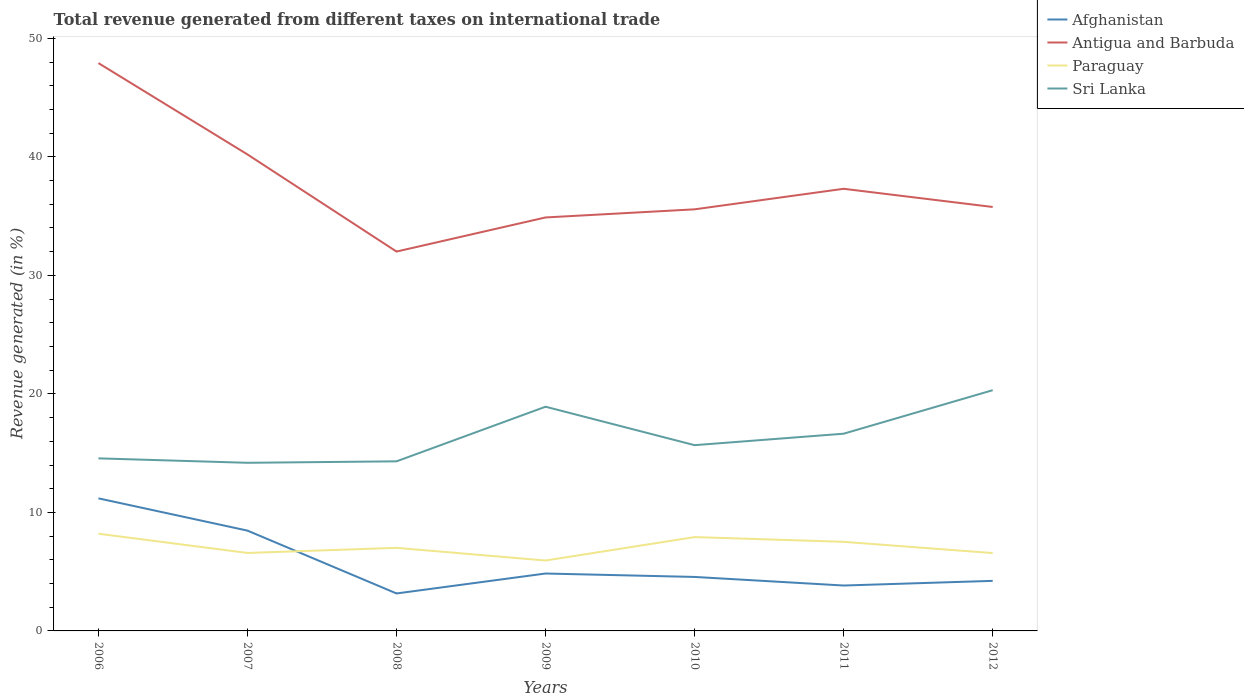Does the line corresponding to Paraguay intersect with the line corresponding to Sri Lanka?
Provide a short and direct response. No. Across all years, what is the maximum total revenue generated in Afghanistan?
Offer a very short reply. 3.16. What is the total total revenue generated in Antigua and Barbuda in the graph?
Provide a short and direct response. 12.34. What is the difference between the highest and the second highest total revenue generated in Paraguay?
Provide a succinct answer. 2.26. What is the difference between the highest and the lowest total revenue generated in Afghanistan?
Your answer should be compact. 2. How many lines are there?
Offer a terse response. 4. How many years are there in the graph?
Keep it short and to the point. 7. Does the graph contain any zero values?
Offer a terse response. No. Where does the legend appear in the graph?
Ensure brevity in your answer.  Top right. How many legend labels are there?
Ensure brevity in your answer.  4. What is the title of the graph?
Ensure brevity in your answer.  Total revenue generated from different taxes on international trade. Does "South Asia" appear as one of the legend labels in the graph?
Provide a short and direct response. No. What is the label or title of the X-axis?
Provide a succinct answer. Years. What is the label or title of the Y-axis?
Make the answer very short. Revenue generated (in %). What is the Revenue generated (in %) of Afghanistan in 2006?
Your answer should be compact. 11.19. What is the Revenue generated (in %) in Antigua and Barbuda in 2006?
Provide a short and direct response. 47.91. What is the Revenue generated (in %) in Paraguay in 2006?
Give a very brief answer. 8.2. What is the Revenue generated (in %) of Sri Lanka in 2006?
Provide a short and direct response. 14.56. What is the Revenue generated (in %) in Afghanistan in 2007?
Make the answer very short. 8.46. What is the Revenue generated (in %) of Antigua and Barbuda in 2007?
Your answer should be compact. 40.2. What is the Revenue generated (in %) in Paraguay in 2007?
Give a very brief answer. 6.58. What is the Revenue generated (in %) of Sri Lanka in 2007?
Your answer should be very brief. 14.19. What is the Revenue generated (in %) in Afghanistan in 2008?
Offer a very short reply. 3.16. What is the Revenue generated (in %) in Antigua and Barbuda in 2008?
Offer a terse response. 32.01. What is the Revenue generated (in %) in Paraguay in 2008?
Your response must be concise. 7.01. What is the Revenue generated (in %) in Sri Lanka in 2008?
Make the answer very short. 14.31. What is the Revenue generated (in %) of Afghanistan in 2009?
Your response must be concise. 4.84. What is the Revenue generated (in %) in Antigua and Barbuda in 2009?
Provide a succinct answer. 34.89. What is the Revenue generated (in %) in Paraguay in 2009?
Make the answer very short. 5.94. What is the Revenue generated (in %) in Sri Lanka in 2009?
Your answer should be very brief. 18.92. What is the Revenue generated (in %) in Afghanistan in 2010?
Provide a short and direct response. 4.55. What is the Revenue generated (in %) of Antigua and Barbuda in 2010?
Provide a succinct answer. 35.57. What is the Revenue generated (in %) of Paraguay in 2010?
Provide a short and direct response. 7.92. What is the Revenue generated (in %) of Sri Lanka in 2010?
Keep it short and to the point. 15.67. What is the Revenue generated (in %) in Afghanistan in 2011?
Provide a short and direct response. 3.83. What is the Revenue generated (in %) in Antigua and Barbuda in 2011?
Your answer should be very brief. 37.31. What is the Revenue generated (in %) in Paraguay in 2011?
Give a very brief answer. 7.52. What is the Revenue generated (in %) of Sri Lanka in 2011?
Offer a very short reply. 16.64. What is the Revenue generated (in %) of Afghanistan in 2012?
Keep it short and to the point. 4.22. What is the Revenue generated (in %) in Antigua and Barbuda in 2012?
Offer a terse response. 35.77. What is the Revenue generated (in %) of Paraguay in 2012?
Offer a very short reply. 6.57. What is the Revenue generated (in %) of Sri Lanka in 2012?
Your response must be concise. 20.31. Across all years, what is the maximum Revenue generated (in %) in Afghanistan?
Provide a succinct answer. 11.19. Across all years, what is the maximum Revenue generated (in %) in Antigua and Barbuda?
Your answer should be compact. 47.91. Across all years, what is the maximum Revenue generated (in %) in Paraguay?
Your answer should be very brief. 8.2. Across all years, what is the maximum Revenue generated (in %) in Sri Lanka?
Your response must be concise. 20.31. Across all years, what is the minimum Revenue generated (in %) in Afghanistan?
Offer a very short reply. 3.16. Across all years, what is the minimum Revenue generated (in %) in Antigua and Barbuda?
Your response must be concise. 32.01. Across all years, what is the minimum Revenue generated (in %) of Paraguay?
Give a very brief answer. 5.94. Across all years, what is the minimum Revenue generated (in %) of Sri Lanka?
Your response must be concise. 14.19. What is the total Revenue generated (in %) of Afghanistan in the graph?
Your response must be concise. 40.27. What is the total Revenue generated (in %) of Antigua and Barbuda in the graph?
Make the answer very short. 263.67. What is the total Revenue generated (in %) of Paraguay in the graph?
Provide a succinct answer. 49.73. What is the total Revenue generated (in %) in Sri Lanka in the graph?
Offer a terse response. 114.6. What is the difference between the Revenue generated (in %) in Afghanistan in 2006 and that in 2007?
Offer a very short reply. 2.72. What is the difference between the Revenue generated (in %) in Antigua and Barbuda in 2006 and that in 2007?
Your answer should be very brief. 7.71. What is the difference between the Revenue generated (in %) in Paraguay in 2006 and that in 2007?
Your response must be concise. 1.62. What is the difference between the Revenue generated (in %) of Sri Lanka in 2006 and that in 2007?
Your answer should be compact. 0.38. What is the difference between the Revenue generated (in %) of Afghanistan in 2006 and that in 2008?
Ensure brevity in your answer.  8.02. What is the difference between the Revenue generated (in %) in Antigua and Barbuda in 2006 and that in 2008?
Keep it short and to the point. 15.9. What is the difference between the Revenue generated (in %) in Paraguay in 2006 and that in 2008?
Provide a short and direct response. 1.19. What is the difference between the Revenue generated (in %) of Sri Lanka in 2006 and that in 2008?
Make the answer very short. 0.25. What is the difference between the Revenue generated (in %) of Afghanistan in 2006 and that in 2009?
Give a very brief answer. 6.34. What is the difference between the Revenue generated (in %) in Antigua and Barbuda in 2006 and that in 2009?
Offer a terse response. 13.02. What is the difference between the Revenue generated (in %) in Paraguay in 2006 and that in 2009?
Your answer should be very brief. 2.26. What is the difference between the Revenue generated (in %) in Sri Lanka in 2006 and that in 2009?
Your answer should be very brief. -4.36. What is the difference between the Revenue generated (in %) in Afghanistan in 2006 and that in 2010?
Your response must be concise. 6.63. What is the difference between the Revenue generated (in %) of Antigua and Barbuda in 2006 and that in 2010?
Provide a succinct answer. 12.34. What is the difference between the Revenue generated (in %) of Paraguay in 2006 and that in 2010?
Offer a very short reply. 0.28. What is the difference between the Revenue generated (in %) in Sri Lanka in 2006 and that in 2010?
Your answer should be very brief. -1.11. What is the difference between the Revenue generated (in %) of Afghanistan in 2006 and that in 2011?
Offer a very short reply. 7.35. What is the difference between the Revenue generated (in %) of Antigua and Barbuda in 2006 and that in 2011?
Your answer should be compact. 10.61. What is the difference between the Revenue generated (in %) in Paraguay in 2006 and that in 2011?
Give a very brief answer. 0.68. What is the difference between the Revenue generated (in %) in Sri Lanka in 2006 and that in 2011?
Make the answer very short. -2.08. What is the difference between the Revenue generated (in %) in Afghanistan in 2006 and that in 2012?
Your answer should be compact. 6.96. What is the difference between the Revenue generated (in %) in Antigua and Barbuda in 2006 and that in 2012?
Keep it short and to the point. 12.14. What is the difference between the Revenue generated (in %) of Paraguay in 2006 and that in 2012?
Keep it short and to the point. 1.63. What is the difference between the Revenue generated (in %) of Sri Lanka in 2006 and that in 2012?
Give a very brief answer. -5.75. What is the difference between the Revenue generated (in %) of Afghanistan in 2007 and that in 2008?
Ensure brevity in your answer.  5.3. What is the difference between the Revenue generated (in %) of Antigua and Barbuda in 2007 and that in 2008?
Make the answer very short. 8.19. What is the difference between the Revenue generated (in %) in Paraguay in 2007 and that in 2008?
Your answer should be compact. -0.43. What is the difference between the Revenue generated (in %) in Sri Lanka in 2007 and that in 2008?
Provide a succinct answer. -0.12. What is the difference between the Revenue generated (in %) of Afghanistan in 2007 and that in 2009?
Keep it short and to the point. 3.62. What is the difference between the Revenue generated (in %) of Antigua and Barbuda in 2007 and that in 2009?
Provide a succinct answer. 5.32. What is the difference between the Revenue generated (in %) in Paraguay in 2007 and that in 2009?
Your response must be concise. 0.64. What is the difference between the Revenue generated (in %) of Sri Lanka in 2007 and that in 2009?
Ensure brevity in your answer.  -4.73. What is the difference between the Revenue generated (in %) of Afghanistan in 2007 and that in 2010?
Make the answer very short. 3.91. What is the difference between the Revenue generated (in %) of Antigua and Barbuda in 2007 and that in 2010?
Your response must be concise. 4.63. What is the difference between the Revenue generated (in %) in Paraguay in 2007 and that in 2010?
Your response must be concise. -1.34. What is the difference between the Revenue generated (in %) of Sri Lanka in 2007 and that in 2010?
Offer a very short reply. -1.49. What is the difference between the Revenue generated (in %) of Afghanistan in 2007 and that in 2011?
Make the answer very short. 4.63. What is the difference between the Revenue generated (in %) in Antigua and Barbuda in 2007 and that in 2011?
Provide a short and direct response. 2.9. What is the difference between the Revenue generated (in %) of Paraguay in 2007 and that in 2011?
Keep it short and to the point. -0.94. What is the difference between the Revenue generated (in %) of Sri Lanka in 2007 and that in 2011?
Your answer should be compact. -2.46. What is the difference between the Revenue generated (in %) in Afghanistan in 2007 and that in 2012?
Your answer should be compact. 4.24. What is the difference between the Revenue generated (in %) in Antigua and Barbuda in 2007 and that in 2012?
Give a very brief answer. 4.43. What is the difference between the Revenue generated (in %) in Paraguay in 2007 and that in 2012?
Make the answer very short. 0.01. What is the difference between the Revenue generated (in %) in Sri Lanka in 2007 and that in 2012?
Your answer should be compact. -6.13. What is the difference between the Revenue generated (in %) in Afghanistan in 2008 and that in 2009?
Provide a short and direct response. -1.68. What is the difference between the Revenue generated (in %) of Antigua and Barbuda in 2008 and that in 2009?
Your answer should be very brief. -2.88. What is the difference between the Revenue generated (in %) of Paraguay in 2008 and that in 2009?
Keep it short and to the point. 1.07. What is the difference between the Revenue generated (in %) of Sri Lanka in 2008 and that in 2009?
Provide a succinct answer. -4.61. What is the difference between the Revenue generated (in %) of Afghanistan in 2008 and that in 2010?
Ensure brevity in your answer.  -1.39. What is the difference between the Revenue generated (in %) of Antigua and Barbuda in 2008 and that in 2010?
Your response must be concise. -3.56. What is the difference between the Revenue generated (in %) in Paraguay in 2008 and that in 2010?
Ensure brevity in your answer.  -0.91. What is the difference between the Revenue generated (in %) of Sri Lanka in 2008 and that in 2010?
Ensure brevity in your answer.  -1.36. What is the difference between the Revenue generated (in %) of Afghanistan in 2008 and that in 2011?
Give a very brief answer. -0.67. What is the difference between the Revenue generated (in %) in Antigua and Barbuda in 2008 and that in 2011?
Offer a terse response. -5.3. What is the difference between the Revenue generated (in %) in Paraguay in 2008 and that in 2011?
Offer a terse response. -0.51. What is the difference between the Revenue generated (in %) of Sri Lanka in 2008 and that in 2011?
Keep it short and to the point. -2.33. What is the difference between the Revenue generated (in %) of Afghanistan in 2008 and that in 2012?
Make the answer very short. -1.06. What is the difference between the Revenue generated (in %) in Antigua and Barbuda in 2008 and that in 2012?
Provide a short and direct response. -3.76. What is the difference between the Revenue generated (in %) of Paraguay in 2008 and that in 2012?
Offer a very short reply. 0.44. What is the difference between the Revenue generated (in %) of Sri Lanka in 2008 and that in 2012?
Your answer should be very brief. -6. What is the difference between the Revenue generated (in %) in Afghanistan in 2009 and that in 2010?
Offer a very short reply. 0.29. What is the difference between the Revenue generated (in %) in Antigua and Barbuda in 2009 and that in 2010?
Provide a short and direct response. -0.69. What is the difference between the Revenue generated (in %) of Paraguay in 2009 and that in 2010?
Give a very brief answer. -1.98. What is the difference between the Revenue generated (in %) in Sri Lanka in 2009 and that in 2010?
Your response must be concise. 3.24. What is the difference between the Revenue generated (in %) of Afghanistan in 2009 and that in 2011?
Your answer should be very brief. 1.01. What is the difference between the Revenue generated (in %) of Antigua and Barbuda in 2009 and that in 2011?
Provide a short and direct response. -2.42. What is the difference between the Revenue generated (in %) in Paraguay in 2009 and that in 2011?
Offer a very short reply. -1.58. What is the difference between the Revenue generated (in %) of Sri Lanka in 2009 and that in 2011?
Make the answer very short. 2.28. What is the difference between the Revenue generated (in %) in Afghanistan in 2009 and that in 2012?
Provide a succinct answer. 0.62. What is the difference between the Revenue generated (in %) of Antigua and Barbuda in 2009 and that in 2012?
Ensure brevity in your answer.  -0.88. What is the difference between the Revenue generated (in %) of Paraguay in 2009 and that in 2012?
Ensure brevity in your answer.  -0.63. What is the difference between the Revenue generated (in %) of Sri Lanka in 2009 and that in 2012?
Your response must be concise. -1.39. What is the difference between the Revenue generated (in %) of Afghanistan in 2010 and that in 2011?
Your answer should be very brief. 0.72. What is the difference between the Revenue generated (in %) of Antigua and Barbuda in 2010 and that in 2011?
Your answer should be very brief. -1.73. What is the difference between the Revenue generated (in %) of Paraguay in 2010 and that in 2011?
Offer a terse response. 0.4. What is the difference between the Revenue generated (in %) of Sri Lanka in 2010 and that in 2011?
Provide a succinct answer. -0.97. What is the difference between the Revenue generated (in %) of Afghanistan in 2010 and that in 2012?
Make the answer very short. 0.33. What is the difference between the Revenue generated (in %) in Antigua and Barbuda in 2010 and that in 2012?
Offer a very short reply. -0.2. What is the difference between the Revenue generated (in %) of Paraguay in 2010 and that in 2012?
Your answer should be compact. 1.35. What is the difference between the Revenue generated (in %) in Sri Lanka in 2010 and that in 2012?
Give a very brief answer. -4.64. What is the difference between the Revenue generated (in %) of Afghanistan in 2011 and that in 2012?
Ensure brevity in your answer.  -0.39. What is the difference between the Revenue generated (in %) in Antigua and Barbuda in 2011 and that in 2012?
Provide a short and direct response. 1.53. What is the difference between the Revenue generated (in %) in Paraguay in 2011 and that in 2012?
Offer a terse response. 0.95. What is the difference between the Revenue generated (in %) in Sri Lanka in 2011 and that in 2012?
Offer a very short reply. -3.67. What is the difference between the Revenue generated (in %) in Afghanistan in 2006 and the Revenue generated (in %) in Antigua and Barbuda in 2007?
Offer a terse response. -29.02. What is the difference between the Revenue generated (in %) of Afghanistan in 2006 and the Revenue generated (in %) of Paraguay in 2007?
Offer a very short reply. 4.61. What is the difference between the Revenue generated (in %) of Afghanistan in 2006 and the Revenue generated (in %) of Sri Lanka in 2007?
Ensure brevity in your answer.  -3. What is the difference between the Revenue generated (in %) in Antigua and Barbuda in 2006 and the Revenue generated (in %) in Paraguay in 2007?
Offer a terse response. 41.33. What is the difference between the Revenue generated (in %) in Antigua and Barbuda in 2006 and the Revenue generated (in %) in Sri Lanka in 2007?
Keep it short and to the point. 33.73. What is the difference between the Revenue generated (in %) in Paraguay in 2006 and the Revenue generated (in %) in Sri Lanka in 2007?
Give a very brief answer. -5.98. What is the difference between the Revenue generated (in %) in Afghanistan in 2006 and the Revenue generated (in %) in Antigua and Barbuda in 2008?
Provide a short and direct response. -20.82. What is the difference between the Revenue generated (in %) in Afghanistan in 2006 and the Revenue generated (in %) in Paraguay in 2008?
Your answer should be compact. 4.18. What is the difference between the Revenue generated (in %) of Afghanistan in 2006 and the Revenue generated (in %) of Sri Lanka in 2008?
Provide a short and direct response. -3.12. What is the difference between the Revenue generated (in %) in Antigua and Barbuda in 2006 and the Revenue generated (in %) in Paraguay in 2008?
Offer a very short reply. 40.9. What is the difference between the Revenue generated (in %) in Antigua and Barbuda in 2006 and the Revenue generated (in %) in Sri Lanka in 2008?
Ensure brevity in your answer.  33.6. What is the difference between the Revenue generated (in %) in Paraguay in 2006 and the Revenue generated (in %) in Sri Lanka in 2008?
Your response must be concise. -6.11. What is the difference between the Revenue generated (in %) in Afghanistan in 2006 and the Revenue generated (in %) in Antigua and Barbuda in 2009?
Your answer should be compact. -23.7. What is the difference between the Revenue generated (in %) of Afghanistan in 2006 and the Revenue generated (in %) of Paraguay in 2009?
Provide a succinct answer. 5.24. What is the difference between the Revenue generated (in %) of Afghanistan in 2006 and the Revenue generated (in %) of Sri Lanka in 2009?
Offer a terse response. -7.73. What is the difference between the Revenue generated (in %) in Antigua and Barbuda in 2006 and the Revenue generated (in %) in Paraguay in 2009?
Offer a very short reply. 41.97. What is the difference between the Revenue generated (in %) in Antigua and Barbuda in 2006 and the Revenue generated (in %) in Sri Lanka in 2009?
Provide a short and direct response. 29. What is the difference between the Revenue generated (in %) in Paraguay in 2006 and the Revenue generated (in %) in Sri Lanka in 2009?
Your answer should be very brief. -10.72. What is the difference between the Revenue generated (in %) of Afghanistan in 2006 and the Revenue generated (in %) of Antigua and Barbuda in 2010?
Keep it short and to the point. -24.39. What is the difference between the Revenue generated (in %) of Afghanistan in 2006 and the Revenue generated (in %) of Paraguay in 2010?
Your response must be concise. 3.27. What is the difference between the Revenue generated (in %) in Afghanistan in 2006 and the Revenue generated (in %) in Sri Lanka in 2010?
Your answer should be very brief. -4.49. What is the difference between the Revenue generated (in %) in Antigua and Barbuda in 2006 and the Revenue generated (in %) in Paraguay in 2010?
Your answer should be very brief. 39.99. What is the difference between the Revenue generated (in %) in Antigua and Barbuda in 2006 and the Revenue generated (in %) in Sri Lanka in 2010?
Your response must be concise. 32.24. What is the difference between the Revenue generated (in %) in Paraguay in 2006 and the Revenue generated (in %) in Sri Lanka in 2010?
Your answer should be compact. -7.47. What is the difference between the Revenue generated (in %) of Afghanistan in 2006 and the Revenue generated (in %) of Antigua and Barbuda in 2011?
Offer a very short reply. -26.12. What is the difference between the Revenue generated (in %) of Afghanistan in 2006 and the Revenue generated (in %) of Paraguay in 2011?
Provide a succinct answer. 3.67. What is the difference between the Revenue generated (in %) in Afghanistan in 2006 and the Revenue generated (in %) in Sri Lanka in 2011?
Make the answer very short. -5.46. What is the difference between the Revenue generated (in %) in Antigua and Barbuda in 2006 and the Revenue generated (in %) in Paraguay in 2011?
Provide a short and direct response. 40.4. What is the difference between the Revenue generated (in %) of Antigua and Barbuda in 2006 and the Revenue generated (in %) of Sri Lanka in 2011?
Make the answer very short. 31.27. What is the difference between the Revenue generated (in %) of Paraguay in 2006 and the Revenue generated (in %) of Sri Lanka in 2011?
Your answer should be compact. -8.44. What is the difference between the Revenue generated (in %) in Afghanistan in 2006 and the Revenue generated (in %) in Antigua and Barbuda in 2012?
Your answer should be very brief. -24.59. What is the difference between the Revenue generated (in %) in Afghanistan in 2006 and the Revenue generated (in %) in Paraguay in 2012?
Your answer should be compact. 4.62. What is the difference between the Revenue generated (in %) in Afghanistan in 2006 and the Revenue generated (in %) in Sri Lanka in 2012?
Offer a terse response. -9.13. What is the difference between the Revenue generated (in %) of Antigua and Barbuda in 2006 and the Revenue generated (in %) of Paraguay in 2012?
Make the answer very short. 41.34. What is the difference between the Revenue generated (in %) in Antigua and Barbuda in 2006 and the Revenue generated (in %) in Sri Lanka in 2012?
Offer a terse response. 27.6. What is the difference between the Revenue generated (in %) of Paraguay in 2006 and the Revenue generated (in %) of Sri Lanka in 2012?
Your response must be concise. -12.11. What is the difference between the Revenue generated (in %) in Afghanistan in 2007 and the Revenue generated (in %) in Antigua and Barbuda in 2008?
Keep it short and to the point. -23.55. What is the difference between the Revenue generated (in %) of Afghanistan in 2007 and the Revenue generated (in %) of Paraguay in 2008?
Your response must be concise. 1.45. What is the difference between the Revenue generated (in %) in Afghanistan in 2007 and the Revenue generated (in %) in Sri Lanka in 2008?
Give a very brief answer. -5.85. What is the difference between the Revenue generated (in %) of Antigua and Barbuda in 2007 and the Revenue generated (in %) of Paraguay in 2008?
Your response must be concise. 33.19. What is the difference between the Revenue generated (in %) of Antigua and Barbuda in 2007 and the Revenue generated (in %) of Sri Lanka in 2008?
Your response must be concise. 25.89. What is the difference between the Revenue generated (in %) of Paraguay in 2007 and the Revenue generated (in %) of Sri Lanka in 2008?
Keep it short and to the point. -7.73. What is the difference between the Revenue generated (in %) of Afghanistan in 2007 and the Revenue generated (in %) of Antigua and Barbuda in 2009?
Provide a short and direct response. -26.42. What is the difference between the Revenue generated (in %) in Afghanistan in 2007 and the Revenue generated (in %) in Paraguay in 2009?
Your answer should be very brief. 2.52. What is the difference between the Revenue generated (in %) of Afghanistan in 2007 and the Revenue generated (in %) of Sri Lanka in 2009?
Offer a terse response. -10.45. What is the difference between the Revenue generated (in %) in Antigua and Barbuda in 2007 and the Revenue generated (in %) in Paraguay in 2009?
Your answer should be compact. 34.26. What is the difference between the Revenue generated (in %) of Antigua and Barbuda in 2007 and the Revenue generated (in %) of Sri Lanka in 2009?
Offer a terse response. 21.29. What is the difference between the Revenue generated (in %) in Paraguay in 2007 and the Revenue generated (in %) in Sri Lanka in 2009?
Give a very brief answer. -12.34. What is the difference between the Revenue generated (in %) in Afghanistan in 2007 and the Revenue generated (in %) in Antigua and Barbuda in 2010?
Make the answer very short. -27.11. What is the difference between the Revenue generated (in %) of Afghanistan in 2007 and the Revenue generated (in %) of Paraguay in 2010?
Ensure brevity in your answer.  0.55. What is the difference between the Revenue generated (in %) in Afghanistan in 2007 and the Revenue generated (in %) in Sri Lanka in 2010?
Your answer should be compact. -7.21. What is the difference between the Revenue generated (in %) of Antigua and Barbuda in 2007 and the Revenue generated (in %) of Paraguay in 2010?
Offer a very short reply. 32.29. What is the difference between the Revenue generated (in %) in Antigua and Barbuda in 2007 and the Revenue generated (in %) in Sri Lanka in 2010?
Provide a short and direct response. 24.53. What is the difference between the Revenue generated (in %) of Paraguay in 2007 and the Revenue generated (in %) of Sri Lanka in 2010?
Provide a succinct answer. -9.09. What is the difference between the Revenue generated (in %) of Afghanistan in 2007 and the Revenue generated (in %) of Antigua and Barbuda in 2011?
Make the answer very short. -28.84. What is the difference between the Revenue generated (in %) in Afghanistan in 2007 and the Revenue generated (in %) in Paraguay in 2011?
Offer a very short reply. 0.95. What is the difference between the Revenue generated (in %) of Afghanistan in 2007 and the Revenue generated (in %) of Sri Lanka in 2011?
Your answer should be very brief. -8.18. What is the difference between the Revenue generated (in %) in Antigua and Barbuda in 2007 and the Revenue generated (in %) in Paraguay in 2011?
Keep it short and to the point. 32.69. What is the difference between the Revenue generated (in %) of Antigua and Barbuda in 2007 and the Revenue generated (in %) of Sri Lanka in 2011?
Your answer should be compact. 23.56. What is the difference between the Revenue generated (in %) of Paraguay in 2007 and the Revenue generated (in %) of Sri Lanka in 2011?
Make the answer very short. -10.06. What is the difference between the Revenue generated (in %) in Afghanistan in 2007 and the Revenue generated (in %) in Antigua and Barbuda in 2012?
Provide a short and direct response. -27.31. What is the difference between the Revenue generated (in %) in Afghanistan in 2007 and the Revenue generated (in %) in Paraguay in 2012?
Provide a short and direct response. 1.89. What is the difference between the Revenue generated (in %) in Afghanistan in 2007 and the Revenue generated (in %) in Sri Lanka in 2012?
Provide a short and direct response. -11.85. What is the difference between the Revenue generated (in %) of Antigua and Barbuda in 2007 and the Revenue generated (in %) of Paraguay in 2012?
Make the answer very short. 33.63. What is the difference between the Revenue generated (in %) of Antigua and Barbuda in 2007 and the Revenue generated (in %) of Sri Lanka in 2012?
Ensure brevity in your answer.  19.89. What is the difference between the Revenue generated (in %) of Paraguay in 2007 and the Revenue generated (in %) of Sri Lanka in 2012?
Provide a succinct answer. -13.73. What is the difference between the Revenue generated (in %) of Afghanistan in 2008 and the Revenue generated (in %) of Antigua and Barbuda in 2009?
Keep it short and to the point. -31.73. What is the difference between the Revenue generated (in %) in Afghanistan in 2008 and the Revenue generated (in %) in Paraguay in 2009?
Your response must be concise. -2.78. What is the difference between the Revenue generated (in %) in Afghanistan in 2008 and the Revenue generated (in %) in Sri Lanka in 2009?
Provide a succinct answer. -15.76. What is the difference between the Revenue generated (in %) in Antigua and Barbuda in 2008 and the Revenue generated (in %) in Paraguay in 2009?
Keep it short and to the point. 26.07. What is the difference between the Revenue generated (in %) of Antigua and Barbuda in 2008 and the Revenue generated (in %) of Sri Lanka in 2009?
Give a very brief answer. 13.09. What is the difference between the Revenue generated (in %) in Paraguay in 2008 and the Revenue generated (in %) in Sri Lanka in 2009?
Your response must be concise. -11.91. What is the difference between the Revenue generated (in %) in Afghanistan in 2008 and the Revenue generated (in %) in Antigua and Barbuda in 2010?
Make the answer very short. -32.41. What is the difference between the Revenue generated (in %) in Afghanistan in 2008 and the Revenue generated (in %) in Paraguay in 2010?
Make the answer very short. -4.76. What is the difference between the Revenue generated (in %) in Afghanistan in 2008 and the Revenue generated (in %) in Sri Lanka in 2010?
Give a very brief answer. -12.51. What is the difference between the Revenue generated (in %) in Antigua and Barbuda in 2008 and the Revenue generated (in %) in Paraguay in 2010?
Keep it short and to the point. 24.09. What is the difference between the Revenue generated (in %) of Antigua and Barbuda in 2008 and the Revenue generated (in %) of Sri Lanka in 2010?
Your answer should be very brief. 16.34. What is the difference between the Revenue generated (in %) in Paraguay in 2008 and the Revenue generated (in %) in Sri Lanka in 2010?
Give a very brief answer. -8.66. What is the difference between the Revenue generated (in %) of Afghanistan in 2008 and the Revenue generated (in %) of Antigua and Barbuda in 2011?
Provide a succinct answer. -34.14. What is the difference between the Revenue generated (in %) of Afghanistan in 2008 and the Revenue generated (in %) of Paraguay in 2011?
Your answer should be very brief. -4.36. What is the difference between the Revenue generated (in %) of Afghanistan in 2008 and the Revenue generated (in %) of Sri Lanka in 2011?
Your answer should be compact. -13.48. What is the difference between the Revenue generated (in %) in Antigua and Barbuda in 2008 and the Revenue generated (in %) in Paraguay in 2011?
Your answer should be very brief. 24.49. What is the difference between the Revenue generated (in %) in Antigua and Barbuda in 2008 and the Revenue generated (in %) in Sri Lanka in 2011?
Your response must be concise. 15.37. What is the difference between the Revenue generated (in %) of Paraguay in 2008 and the Revenue generated (in %) of Sri Lanka in 2011?
Give a very brief answer. -9.63. What is the difference between the Revenue generated (in %) in Afghanistan in 2008 and the Revenue generated (in %) in Antigua and Barbuda in 2012?
Give a very brief answer. -32.61. What is the difference between the Revenue generated (in %) of Afghanistan in 2008 and the Revenue generated (in %) of Paraguay in 2012?
Ensure brevity in your answer.  -3.41. What is the difference between the Revenue generated (in %) in Afghanistan in 2008 and the Revenue generated (in %) in Sri Lanka in 2012?
Keep it short and to the point. -17.15. What is the difference between the Revenue generated (in %) in Antigua and Barbuda in 2008 and the Revenue generated (in %) in Paraguay in 2012?
Give a very brief answer. 25.44. What is the difference between the Revenue generated (in %) of Antigua and Barbuda in 2008 and the Revenue generated (in %) of Sri Lanka in 2012?
Make the answer very short. 11.7. What is the difference between the Revenue generated (in %) of Paraguay in 2008 and the Revenue generated (in %) of Sri Lanka in 2012?
Offer a terse response. -13.3. What is the difference between the Revenue generated (in %) in Afghanistan in 2009 and the Revenue generated (in %) in Antigua and Barbuda in 2010?
Provide a short and direct response. -30.73. What is the difference between the Revenue generated (in %) of Afghanistan in 2009 and the Revenue generated (in %) of Paraguay in 2010?
Ensure brevity in your answer.  -3.07. What is the difference between the Revenue generated (in %) of Afghanistan in 2009 and the Revenue generated (in %) of Sri Lanka in 2010?
Offer a very short reply. -10.83. What is the difference between the Revenue generated (in %) in Antigua and Barbuda in 2009 and the Revenue generated (in %) in Paraguay in 2010?
Provide a short and direct response. 26.97. What is the difference between the Revenue generated (in %) of Antigua and Barbuda in 2009 and the Revenue generated (in %) of Sri Lanka in 2010?
Give a very brief answer. 19.21. What is the difference between the Revenue generated (in %) of Paraguay in 2009 and the Revenue generated (in %) of Sri Lanka in 2010?
Provide a succinct answer. -9.73. What is the difference between the Revenue generated (in %) of Afghanistan in 2009 and the Revenue generated (in %) of Antigua and Barbuda in 2011?
Offer a terse response. -32.46. What is the difference between the Revenue generated (in %) of Afghanistan in 2009 and the Revenue generated (in %) of Paraguay in 2011?
Your answer should be compact. -2.67. What is the difference between the Revenue generated (in %) of Afghanistan in 2009 and the Revenue generated (in %) of Sri Lanka in 2011?
Ensure brevity in your answer.  -11.8. What is the difference between the Revenue generated (in %) of Antigua and Barbuda in 2009 and the Revenue generated (in %) of Paraguay in 2011?
Make the answer very short. 27.37. What is the difference between the Revenue generated (in %) in Antigua and Barbuda in 2009 and the Revenue generated (in %) in Sri Lanka in 2011?
Provide a succinct answer. 18.25. What is the difference between the Revenue generated (in %) in Paraguay in 2009 and the Revenue generated (in %) in Sri Lanka in 2011?
Keep it short and to the point. -10.7. What is the difference between the Revenue generated (in %) in Afghanistan in 2009 and the Revenue generated (in %) in Antigua and Barbuda in 2012?
Your answer should be very brief. -30.93. What is the difference between the Revenue generated (in %) in Afghanistan in 2009 and the Revenue generated (in %) in Paraguay in 2012?
Offer a very short reply. -1.73. What is the difference between the Revenue generated (in %) in Afghanistan in 2009 and the Revenue generated (in %) in Sri Lanka in 2012?
Your response must be concise. -15.47. What is the difference between the Revenue generated (in %) of Antigua and Barbuda in 2009 and the Revenue generated (in %) of Paraguay in 2012?
Keep it short and to the point. 28.32. What is the difference between the Revenue generated (in %) of Antigua and Barbuda in 2009 and the Revenue generated (in %) of Sri Lanka in 2012?
Provide a short and direct response. 14.58. What is the difference between the Revenue generated (in %) of Paraguay in 2009 and the Revenue generated (in %) of Sri Lanka in 2012?
Your answer should be compact. -14.37. What is the difference between the Revenue generated (in %) in Afghanistan in 2010 and the Revenue generated (in %) in Antigua and Barbuda in 2011?
Provide a succinct answer. -32.75. What is the difference between the Revenue generated (in %) in Afghanistan in 2010 and the Revenue generated (in %) in Paraguay in 2011?
Your response must be concise. -2.96. What is the difference between the Revenue generated (in %) of Afghanistan in 2010 and the Revenue generated (in %) of Sri Lanka in 2011?
Make the answer very short. -12.09. What is the difference between the Revenue generated (in %) in Antigua and Barbuda in 2010 and the Revenue generated (in %) in Paraguay in 2011?
Ensure brevity in your answer.  28.06. What is the difference between the Revenue generated (in %) in Antigua and Barbuda in 2010 and the Revenue generated (in %) in Sri Lanka in 2011?
Your answer should be compact. 18.93. What is the difference between the Revenue generated (in %) of Paraguay in 2010 and the Revenue generated (in %) of Sri Lanka in 2011?
Offer a terse response. -8.72. What is the difference between the Revenue generated (in %) in Afghanistan in 2010 and the Revenue generated (in %) in Antigua and Barbuda in 2012?
Provide a succinct answer. -31.22. What is the difference between the Revenue generated (in %) of Afghanistan in 2010 and the Revenue generated (in %) of Paraguay in 2012?
Provide a succinct answer. -2.01. What is the difference between the Revenue generated (in %) of Afghanistan in 2010 and the Revenue generated (in %) of Sri Lanka in 2012?
Give a very brief answer. -15.76. What is the difference between the Revenue generated (in %) in Antigua and Barbuda in 2010 and the Revenue generated (in %) in Paraguay in 2012?
Your answer should be compact. 29. What is the difference between the Revenue generated (in %) in Antigua and Barbuda in 2010 and the Revenue generated (in %) in Sri Lanka in 2012?
Ensure brevity in your answer.  15.26. What is the difference between the Revenue generated (in %) of Paraguay in 2010 and the Revenue generated (in %) of Sri Lanka in 2012?
Make the answer very short. -12.39. What is the difference between the Revenue generated (in %) in Afghanistan in 2011 and the Revenue generated (in %) in Antigua and Barbuda in 2012?
Give a very brief answer. -31.94. What is the difference between the Revenue generated (in %) of Afghanistan in 2011 and the Revenue generated (in %) of Paraguay in 2012?
Offer a terse response. -2.74. What is the difference between the Revenue generated (in %) of Afghanistan in 2011 and the Revenue generated (in %) of Sri Lanka in 2012?
Offer a terse response. -16.48. What is the difference between the Revenue generated (in %) in Antigua and Barbuda in 2011 and the Revenue generated (in %) in Paraguay in 2012?
Ensure brevity in your answer.  30.74. What is the difference between the Revenue generated (in %) of Antigua and Barbuda in 2011 and the Revenue generated (in %) of Sri Lanka in 2012?
Keep it short and to the point. 16.99. What is the difference between the Revenue generated (in %) in Paraguay in 2011 and the Revenue generated (in %) in Sri Lanka in 2012?
Offer a very short reply. -12.8. What is the average Revenue generated (in %) in Afghanistan per year?
Offer a very short reply. 5.75. What is the average Revenue generated (in %) of Antigua and Barbuda per year?
Your answer should be compact. 37.67. What is the average Revenue generated (in %) in Paraguay per year?
Offer a terse response. 7.11. What is the average Revenue generated (in %) of Sri Lanka per year?
Give a very brief answer. 16.37. In the year 2006, what is the difference between the Revenue generated (in %) of Afghanistan and Revenue generated (in %) of Antigua and Barbuda?
Your response must be concise. -36.73. In the year 2006, what is the difference between the Revenue generated (in %) in Afghanistan and Revenue generated (in %) in Paraguay?
Your answer should be very brief. 2.98. In the year 2006, what is the difference between the Revenue generated (in %) in Afghanistan and Revenue generated (in %) in Sri Lanka?
Keep it short and to the point. -3.38. In the year 2006, what is the difference between the Revenue generated (in %) in Antigua and Barbuda and Revenue generated (in %) in Paraguay?
Offer a very short reply. 39.71. In the year 2006, what is the difference between the Revenue generated (in %) of Antigua and Barbuda and Revenue generated (in %) of Sri Lanka?
Give a very brief answer. 33.35. In the year 2006, what is the difference between the Revenue generated (in %) of Paraguay and Revenue generated (in %) of Sri Lanka?
Offer a terse response. -6.36. In the year 2007, what is the difference between the Revenue generated (in %) of Afghanistan and Revenue generated (in %) of Antigua and Barbuda?
Keep it short and to the point. -31.74. In the year 2007, what is the difference between the Revenue generated (in %) of Afghanistan and Revenue generated (in %) of Paraguay?
Your response must be concise. 1.88. In the year 2007, what is the difference between the Revenue generated (in %) in Afghanistan and Revenue generated (in %) in Sri Lanka?
Provide a short and direct response. -5.72. In the year 2007, what is the difference between the Revenue generated (in %) of Antigua and Barbuda and Revenue generated (in %) of Paraguay?
Your answer should be very brief. 33.62. In the year 2007, what is the difference between the Revenue generated (in %) in Antigua and Barbuda and Revenue generated (in %) in Sri Lanka?
Ensure brevity in your answer.  26.02. In the year 2007, what is the difference between the Revenue generated (in %) in Paraguay and Revenue generated (in %) in Sri Lanka?
Your answer should be compact. -7.61. In the year 2008, what is the difference between the Revenue generated (in %) of Afghanistan and Revenue generated (in %) of Antigua and Barbuda?
Your response must be concise. -28.85. In the year 2008, what is the difference between the Revenue generated (in %) in Afghanistan and Revenue generated (in %) in Paraguay?
Make the answer very short. -3.85. In the year 2008, what is the difference between the Revenue generated (in %) in Afghanistan and Revenue generated (in %) in Sri Lanka?
Keep it short and to the point. -11.15. In the year 2008, what is the difference between the Revenue generated (in %) of Antigua and Barbuda and Revenue generated (in %) of Paraguay?
Your answer should be compact. 25. In the year 2008, what is the difference between the Revenue generated (in %) in Antigua and Barbuda and Revenue generated (in %) in Sri Lanka?
Provide a short and direct response. 17.7. In the year 2008, what is the difference between the Revenue generated (in %) of Paraguay and Revenue generated (in %) of Sri Lanka?
Keep it short and to the point. -7.3. In the year 2009, what is the difference between the Revenue generated (in %) of Afghanistan and Revenue generated (in %) of Antigua and Barbuda?
Offer a terse response. -30.04. In the year 2009, what is the difference between the Revenue generated (in %) of Afghanistan and Revenue generated (in %) of Paraguay?
Provide a succinct answer. -1.1. In the year 2009, what is the difference between the Revenue generated (in %) of Afghanistan and Revenue generated (in %) of Sri Lanka?
Make the answer very short. -14.07. In the year 2009, what is the difference between the Revenue generated (in %) of Antigua and Barbuda and Revenue generated (in %) of Paraguay?
Keep it short and to the point. 28.95. In the year 2009, what is the difference between the Revenue generated (in %) in Antigua and Barbuda and Revenue generated (in %) in Sri Lanka?
Your answer should be compact. 15.97. In the year 2009, what is the difference between the Revenue generated (in %) in Paraguay and Revenue generated (in %) in Sri Lanka?
Provide a short and direct response. -12.98. In the year 2010, what is the difference between the Revenue generated (in %) of Afghanistan and Revenue generated (in %) of Antigua and Barbuda?
Give a very brief answer. -31.02. In the year 2010, what is the difference between the Revenue generated (in %) in Afghanistan and Revenue generated (in %) in Paraguay?
Provide a succinct answer. -3.36. In the year 2010, what is the difference between the Revenue generated (in %) of Afghanistan and Revenue generated (in %) of Sri Lanka?
Offer a terse response. -11.12. In the year 2010, what is the difference between the Revenue generated (in %) of Antigua and Barbuda and Revenue generated (in %) of Paraguay?
Offer a terse response. 27.66. In the year 2010, what is the difference between the Revenue generated (in %) in Antigua and Barbuda and Revenue generated (in %) in Sri Lanka?
Your response must be concise. 19.9. In the year 2010, what is the difference between the Revenue generated (in %) in Paraguay and Revenue generated (in %) in Sri Lanka?
Offer a very short reply. -7.76. In the year 2011, what is the difference between the Revenue generated (in %) of Afghanistan and Revenue generated (in %) of Antigua and Barbuda?
Provide a succinct answer. -33.48. In the year 2011, what is the difference between the Revenue generated (in %) of Afghanistan and Revenue generated (in %) of Paraguay?
Give a very brief answer. -3.69. In the year 2011, what is the difference between the Revenue generated (in %) of Afghanistan and Revenue generated (in %) of Sri Lanka?
Make the answer very short. -12.81. In the year 2011, what is the difference between the Revenue generated (in %) of Antigua and Barbuda and Revenue generated (in %) of Paraguay?
Provide a short and direct response. 29.79. In the year 2011, what is the difference between the Revenue generated (in %) of Antigua and Barbuda and Revenue generated (in %) of Sri Lanka?
Offer a very short reply. 20.66. In the year 2011, what is the difference between the Revenue generated (in %) of Paraguay and Revenue generated (in %) of Sri Lanka?
Provide a short and direct response. -9.12. In the year 2012, what is the difference between the Revenue generated (in %) of Afghanistan and Revenue generated (in %) of Antigua and Barbuda?
Ensure brevity in your answer.  -31.55. In the year 2012, what is the difference between the Revenue generated (in %) of Afghanistan and Revenue generated (in %) of Paraguay?
Keep it short and to the point. -2.34. In the year 2012, what is the difference between the Revenue generated (in %) of Afghanistan and Revenue generated (in %) of Sri Lanka?
Provide a short and direct response. -16.09. In the year 2012, what is the difference between the Revenue generated (in %) of Antigua and Barbuda and Revenue generated (in %) of Paraguay?
Make the answer very short. 29.2. In the year 2012, what is the difference between the Revenue generated (in %) in Antigua and Barbuda and Revenue generated (in %) in Sri Lanka?
Your answer should be compact. 15.46. In the year 2012, what is the difference between the Revenue generated (in %) of Paraguay and Revenue generated (in %) of Sri Lanka?
Ensure brevity in your answer.  -13.74. What is the ratio of the Revenue generated (in %) in Afghanistan in 2006 to that in 2007?
Make the answer very short. 1.32. What is the ratio of the Revenue generated (in %) of Antigua and Barbuda in 2006 to that in 2007?
Keep it short and to the point. 1.19. What is the ratio of the Revenue generated (in %) in Paraguay in 2006 to that in 2007?
Keep it short and to the point. 1.25. What is the ratio of the Revenue generated (in %) in Sri Lanka in 2006 to that in 2007?
Provide a short and direct response. 1.03. What is the ratio of the Revenue generated (in %) in Afghanistan in 2006 to that in 2008?
Make the answer very short. 3.54. What is the ratio of the Revenue generated (in %) of Antigua and Barbuda in 2006 to that in 2008?
Ensure brevity in your answer.  1.5. What is the ratio of the Revenue generated (in %) of Paraguay in 2006 to that in 2008?
Provide a short and direct response. 1.17. What is the ratio of the Revenue generated (in %) in Sri Lanka in 2006 to that in 2008?
Offer a terse response. 1.02. What is the ratio of the Revenue generated (in %) in Afghanistan in 2006 to that in 2009?
Your answer should be compact. 2.31. What is the ratio of the Revenue generated (in %) in Antigua and Barbuda in 2006 to that in 2009?
Your response must be concise. 1.37. What is the ratio of the Revenue generated (in %) of Paraguay in 2006 to that in 2009?
Make the answer very short. 1.38. What is the ratio of the Revenue generated (in %) in Sri Lanka in 2006 to that in 2009?
Provide a short and direct response. 0.77. What is the ratio of the Revenue generated (in %) in Afghanistan in 2006 to that in 2010?
Offer a terse response. 2.46. What is the ratio of the Revenue generated (in %) of Antigua and Barbuda in 2006 to that in 2010?
Offer a terse response. 1.35. What is the ratio of the Revenue generated (in %) of Paraguay in 2006 to that in 2010?
Give a very brief answer. 1.04. What is the ratio of the Revenue generated (in %) of Sri Lanka in 2006 to that in 2010?
Give a very brief answer. 0.93. What is the ratio of the Revenue generated (in %) of Afghanistan in 2006 to that in 2011?
Offer a very short reply. 2.92. What is the ratio of the Revenue generated (in %) of Antigua and Barbuda in 2006 to that in 2011?
Offer a very short reply. 1.28. What is the ratio of the Revenue generated (in %) in Paraguay in 2006 to that in 2011?
Your answer should be very brief. 1.09. What is the ratio of the Revenue generated (in %) of Afghanistan in 2006 to that in 2012?
Offer a very short reply. 2.65. What is the ratio of the Revenue generated (in %) of Antigua and Barbuda in 2006 to that in 2012?
Give a very brief answer. 1.34. What is the ratio of the Revenue generated (in %) in Paraguay in 2006 to that in 2012?
Provide a succinct answer. 1.25. What is the ratio of the Revenue generated (in %) in Sri Lanka in 2006 to that in 2012?
Give a very brief answer. 0.72. What is the ratio of the Revenue generated (in %) in Afghanistan in 2007 to that in 2008?
Give a very brief answer. 2.68. What is the ratio of the Revenue generated (in %) in Antigua and Barbuda in 2007 to that in 2008?
Offer a very short reply. 1.26. What is the ratio of the Revenue generated (in %) in Paraguay in 2007 to that in 2008?
Give a very brief answer. 0.94. What is the ratio of the Revenue generated (in %) in Sri Lanka in 2007 to that in 2008?
Your answer should be compact. 0.99. What is the ratio of the Revenue generated (in %) in Afghanistan in 2007 to that in 2009?
Offer a very short reply. 1.75. What is the ratio of the Revenue generated (in %) in Antigua and Barbuda in 2007 to that in 2009?
Your answer should be compact. 1.15. What is the ratio of the Revenue generated (in %) in Paraguay in 2007 to that in 2009?
Offer a very short reply. 1.11. What is the ratio of the Revenue generated (in %) of Sri Lanka in 2007 to that in 2009?
Provide a succinct answer. 0.75. What is the ratio of the Revenue generated (in %) of Afghanistan in 2007 to that in 2010?
Your answer should be very brief. 1.86. What is the ratio of the Revenue generated (in %) in Antigua and Barbuda in 2007 to that in 2010?
Your answer should be very brief. 1.13. What is the ratio of the Revenue generated (in %) in Paraguay in 2007 to that in 2010?
Provide a short and direct response. 0.83. What is the ratio of the Revenue generated (in %) of Sri Lanka in 2007 to that in 2010?
Provide a succinct answer. 0.91. What is the ratio of the Revenue generated (in %) in Afghanistan in 2007 to that in 2011?
Your response must be concise. 2.21. What is the ratio of the Revenue generated (in %) in Antigua and Barbuda in 2007 to that in 2011?
Give a very brief answer. 1.08. What is the ratio of the Revenue generated (in %) of Paraguay in 2007 to that in 2011?
Your response must be concise. 0.88. What is the ratio of the Revenue generated (in %) of Sri Lanka in 2007 to that in 2011?
Make the answer very short. 0.85. What is the ratio of the Revenue generated (in %) in Afghanistan in 2007 to that in 2012?
Offer a very short reply. 2. What is the ratio of the Revenue generated (in %) of Antigua and Barbuda in 2007 to that in 2012?
Provide a succinct answer. 1.12. What is the ratio of the Revenue generated (in %) of Paraguay in 2007 to that in 2012?
Your answer should be compact. 1. What is the ratio of the Revenue generated (in %) of Sri Lanka in 2007 to that in 2012?
Your answer should be very brief. 0.7. What is the ratio of the Revenue generated (in %) of Afghanistan in 2008 to that in 2009?
Your answer should be compact. 0.65. What is the ratio of the Revenue generated (in %) of Antigua and Barbuda in 2008 to that in 2009?
Your answer should be very brief. 0.92. What is the ratio of the Revenue generated (in %) in Paraguay in 2008 to that in 2009?
Offer a very short reply. 1.18. What is the ratio of the Revenue generated (in %) in Sri Lanka in 2008 to that in 2009?
Offer a very short reply. 0.76. What is the ratio of the Revenue generated (in %) of Afghanistan in 2008 to that in 2010?
Keep it short and to the point. 0.69. What is the ratio of the Revenue generated (in %) of Antigua and Barbuda in 2008 to that in 2010?
Your response must be concise. 0.9. What is the ratio of the Revenue generated (in %) of Paraguay in 2008 to that in 2010?
Your answer should be compact. 0.89. What is the ratio of the Revenue generated (in %) of Afghanistan in 2008 to that in 2011?
Give a very brief answer. 0.83. What is the ratio of the Revenue generated (in %) in Antigua and Barbuda in 2008 to that in 2011?
Your answer should be compact. 0.86. What is the ratio of the Revenue generated (in %) in Paraguay in 2008 to that in 2011?
Provide a succinct answer. 0.93. What is the ratio of the Revenue generated (in %) in Sri Lanka in 2008 to that in 2011?
Your answer should be compact. 0.86. What is the ratio of the Revenue generated (in %) in Afghanistan in 2008 to that in 2012?
Your response must be concise. 0.75. What is the ratio of the Revenue generated (in %) of Antigua and Barbuda in 2008 to that in 2012?
Your response must be concise. 0.89. What is the ratio of the Revenue generated (in %) of Paraguay in 2008 to that in 2012?
Offer a very short reply. 1.07. What is the ratio of the Revenue generated (in %) of Sri Lanka in 2008 to that in 2012?
Offer a very short reply. 0.7. What is the ratio of the Revenue generated (in %) of Afghanistan in 2009 to that in 2010?
Your answer should be very brief. 1.06. What is the ratio of the Revenue generated (in %) in Antigua and Barbuda in 2009 to that in 2010?
Make the answer very short. 0.98. What is the ratio of the Revenue generated (in %) in Paraguay in 2009 to that in 2010?
Ensure brevity in your answer.  0.75. What is the ratio of the Revenue generated (in %) of Sri Lanka in 2009 to that in 2010?
Your answer should be compact. 1.21. What is the ratio of the Revenue generated (in %) of Afghanistan in 2009 to that in 2011?
Your response must be concise. 1.26. What is the ratio of the Revenue generated (in %) of Antigua and Barbuda in 2009 to that in 2011?
Your response must be concise. 0.94. What is the ratio of the Revenue generated (in %) of Paraguay in 2009 to that in 2011?
Provide a succinct answer. 0.79. What is the ratio of the Revenue generated (in %) of Sri Lanka in 2009 to that in 2011?
Provide a succinct answer. 1.14. What is the ratio of the Revenue generated (in %) of Afghanistan in 2009 to that in 2012?
Your answer should be very brief. 1.15. What is the ratio of the Revenue generated (in %) of Antigua and Barbuda in 2009 to that in 2012?
Your answer should be compact. 0.98. What is the ratio of the Revenue generated (in %) in Paraguay in 2009 to that in 2012?
Provide a succinct answer. 0.9. What is the ratio of the Revenue generated (in %) of Sri Lanka in 2009 to that in 2012?
Make the answer very short. 0.93. What is the ratio of the Revenue generated (in %) of Afghanistan in 2010 to that in 2011?
Ensure brevity in your answer.  1.19. What is the ratio of the Revenue generated (in %) in Antigua and Barbuda in 2010 to that in 2011?
Give a very brief answer. 0.95. What is the ratio of the Revenue generated (in %) of Paraguay in 2010 to that in 2011?
Your response must be concise. 1.05. What is the ratio of the Revenue generated (in %) of Sri Lanka in 2010 to that in 2011?
Ensure brevity in your answer.  0.94. What is the ratio of the Revenue generated (in %) of Afghanistan in 2010 to that in 2012?
Provide a short and direct response. 1.08. What is the ratio of the Revenue generated (in %) of Paraguay in 2010 to that in 2012?
Provide a short and direct response. 1.21. What is the ratio of the Revenue generated (in %) in Sri Lanka in 2010 to that in 2012?
Your answer should be very brief. 0.77. What is the ratio of the Revenue generated (in %) in Afghanistan in 2011 to that in 2012?
Your answer should be very brief. 0.91. What is the ratio of the Revenue generated (in %) in Antigua and Barbuda in 2011 to that in 2012?
Offer a very short reply. 1.04. What is the ratio of the Revenue generated (in %) in Paraguay in 2011 to that in 2012?
Offer a very short reply. 1.14. What is the ratio of the Revenue generated (in %) of Sri Lanka in 2011 to that in 2012?
Give a very brief answer. 0.82. What is the difference between the highest and the second highest Revenue generated (in %) in Afghanistan?
Offer a very short reply. 2.72. What is the difference between the highest and the second highest Revenue generated (in %) of Antigua and Barbuda?
Provide a succinct answer. 7.71. What is the difference between the highest and the second highest Revenue generated (in %) in Paraguay?
Offer a terse response. 0.28. What is the difference between the highest and the second highest Revenue generated (in %) in Sri Lanka?
Offer a very short reply. 1.39. What is the difference between the highest and the lowest Revenue generated (in %) of Afghanistan?
Your response must be concise. 8.02. What is the difference between the highest and the lowest Revenue generated (in %) in Antigua and Barbuda?
Your answer should be very brief. 15.9. What is the difference between the highest and the lowest Revenue generated (in %) of Paraguay?
Provide a short and direct response. 2.26. What is the difference between the highest and the lowest Revenue generated (in %) in Sri Lanka?
Your response must be concise. 6.13. 